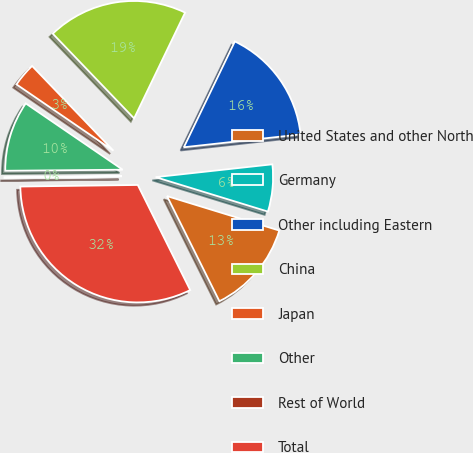<chart> <loc_0><loc_0><loc_500><loc_500><pie_chart><fcel>United States and other North<fcel>Germany<fcel>Other including Eastern<fcel>China<fcel>Japan<fcel>Other<fcel>Rest of World<fcel>Total<nl><fcel>12.9%<fcel>6.48%<fcel>16.11%<fcel>19.32%<fcel>3.28%<fcel>9.69%<fcel>0.07%<fcel>32.15%<nl></chart> 